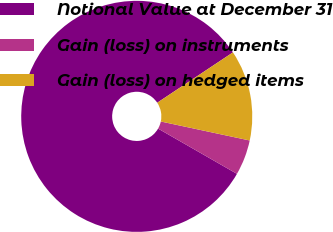Convert chart. <chart><loc_0><loc_0><loc_500><loc_500><pie_chart><fcel>Notional Value at December 31<fcel>Gain (loss) on instruments<fcel>Gain (loss) on hedged items<nl><fcel>82.37%<fcel>4.94%<fcel>12.69%<nl></chart> 